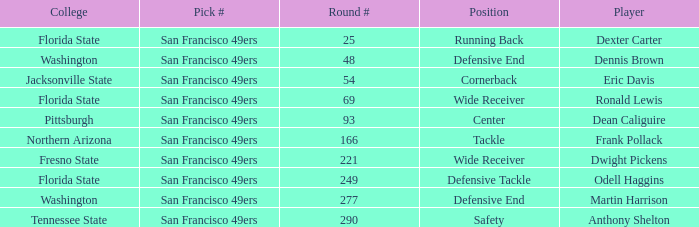What is the College with a Player that is dean caliguire? Pittsburgh. 